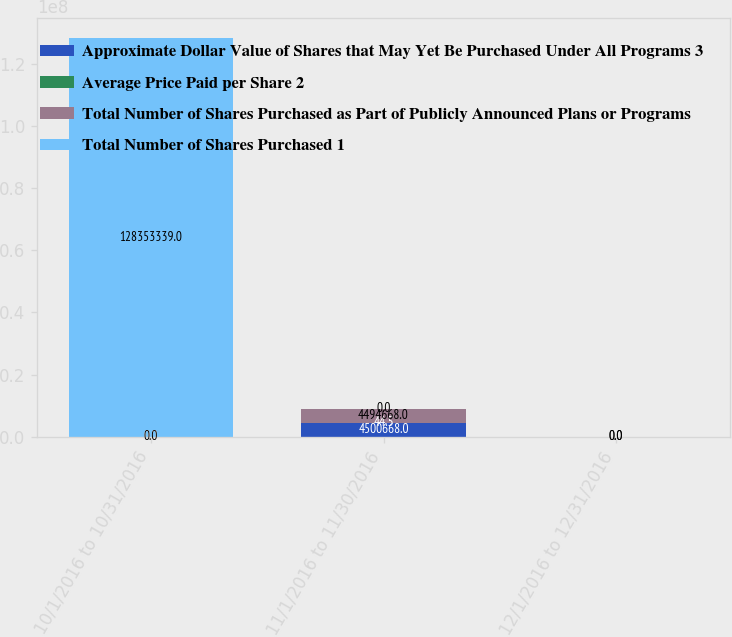Convert chart. <chart><loc_0><loc_0><loc_500><loc_500><stacked_bar_chart><ecel><fcel>10/1/2016 to 10/31/2016<fcel>11/1/2016 to 11/30/2016<fcel>12/1/2016 to 12/31/2016<nl><fcel>Approximate Dollar Value of Shares that May Yet Be Purchased Under All Programs 3<fcel>0<fcel>4.50067e+06<fcel>0<nl><fcel>Average Price Paid per Share 2<fcel>0<fcel>44.5<fcel>0<nl><fcel>Total Number of Shares Purchased as Part of Publicly Announced Plans or Programs<fcel>0<fcel>4.49467e+06<fcel>0<nl><fcel>Total Number of Shares Purchased 1<fcel>1.28353e+08<fcel>0<fcel>0<nl></chart> 